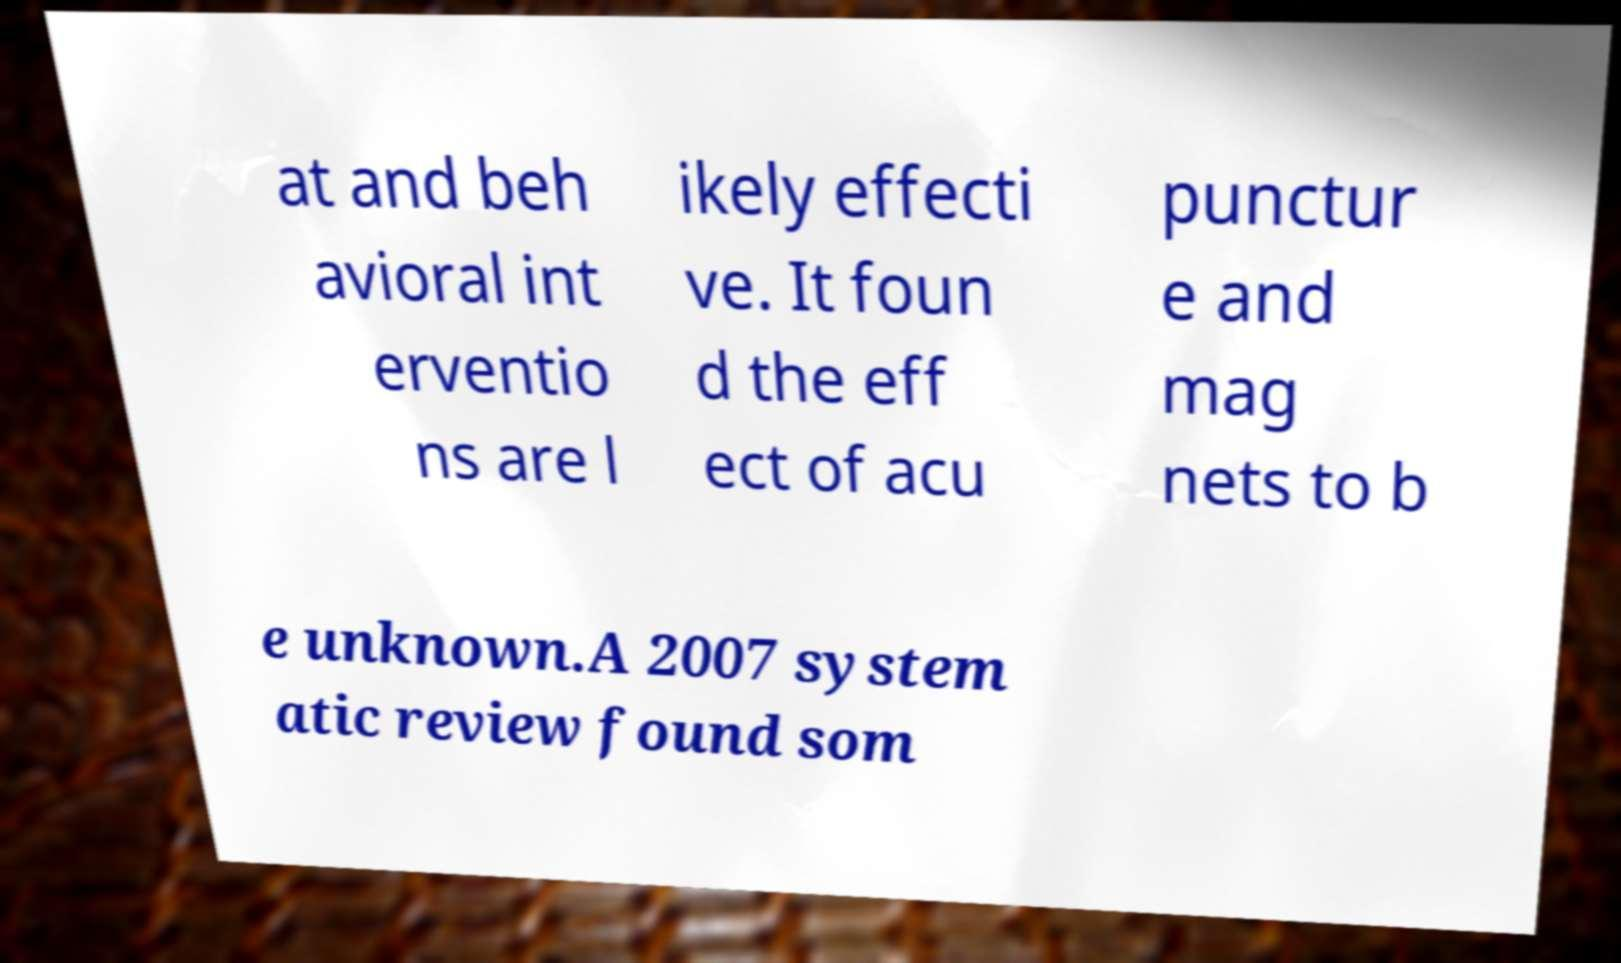Could you assist in decoding the text presented in this image and type it out clearly? at and beh avioral int erventio ns are l ikely effecti ve. It foun d the eff ect of acu punctur e and mag nets to b e unknown.A 2007 system atic review found som 